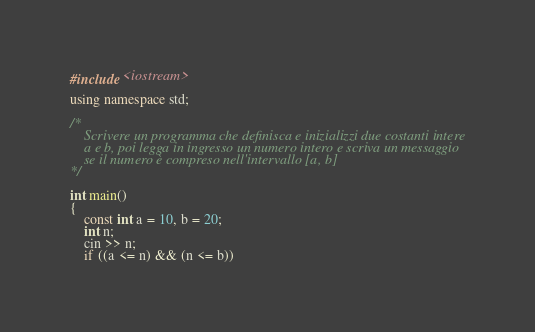Convert code to text. <code><loc_0><loc_0><loc_500><loc_500><_C++_>#include <iostream>

using namespace std;

/*
    Scrivere un programma che definisca e inizializzi due costanti intere
    a e b, poi legga in ingresso un numero intero e scriva un messaggio
    se il numero è compreso nell'intervallo [a, b]
*/

int main()
{
    const int a = 10, b = 20;
    int n;
    cin >> n;
    if ((a <= n) && (n <= b))</code> 